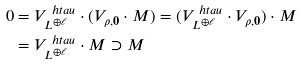Convert formula to latex. <formula><loc_0><loc_0><loc_500><loc_500>0 & = V _ { L ^ { \oplus \ell } } ^ { \ h t a u } \cdot ( V _ { \rho , { \mathbf 0 } } \cdot M ) = ( V _ { L ^ { \oplus \ell } } ^ { \ h t a u } \cdot V _ { \rho , { \mathbf 0 } } ) \cdot M \\ & = V _ { L ^ { \oplus \ell } } ^ { \ h t a u } \cdot M \supset M</formula> 